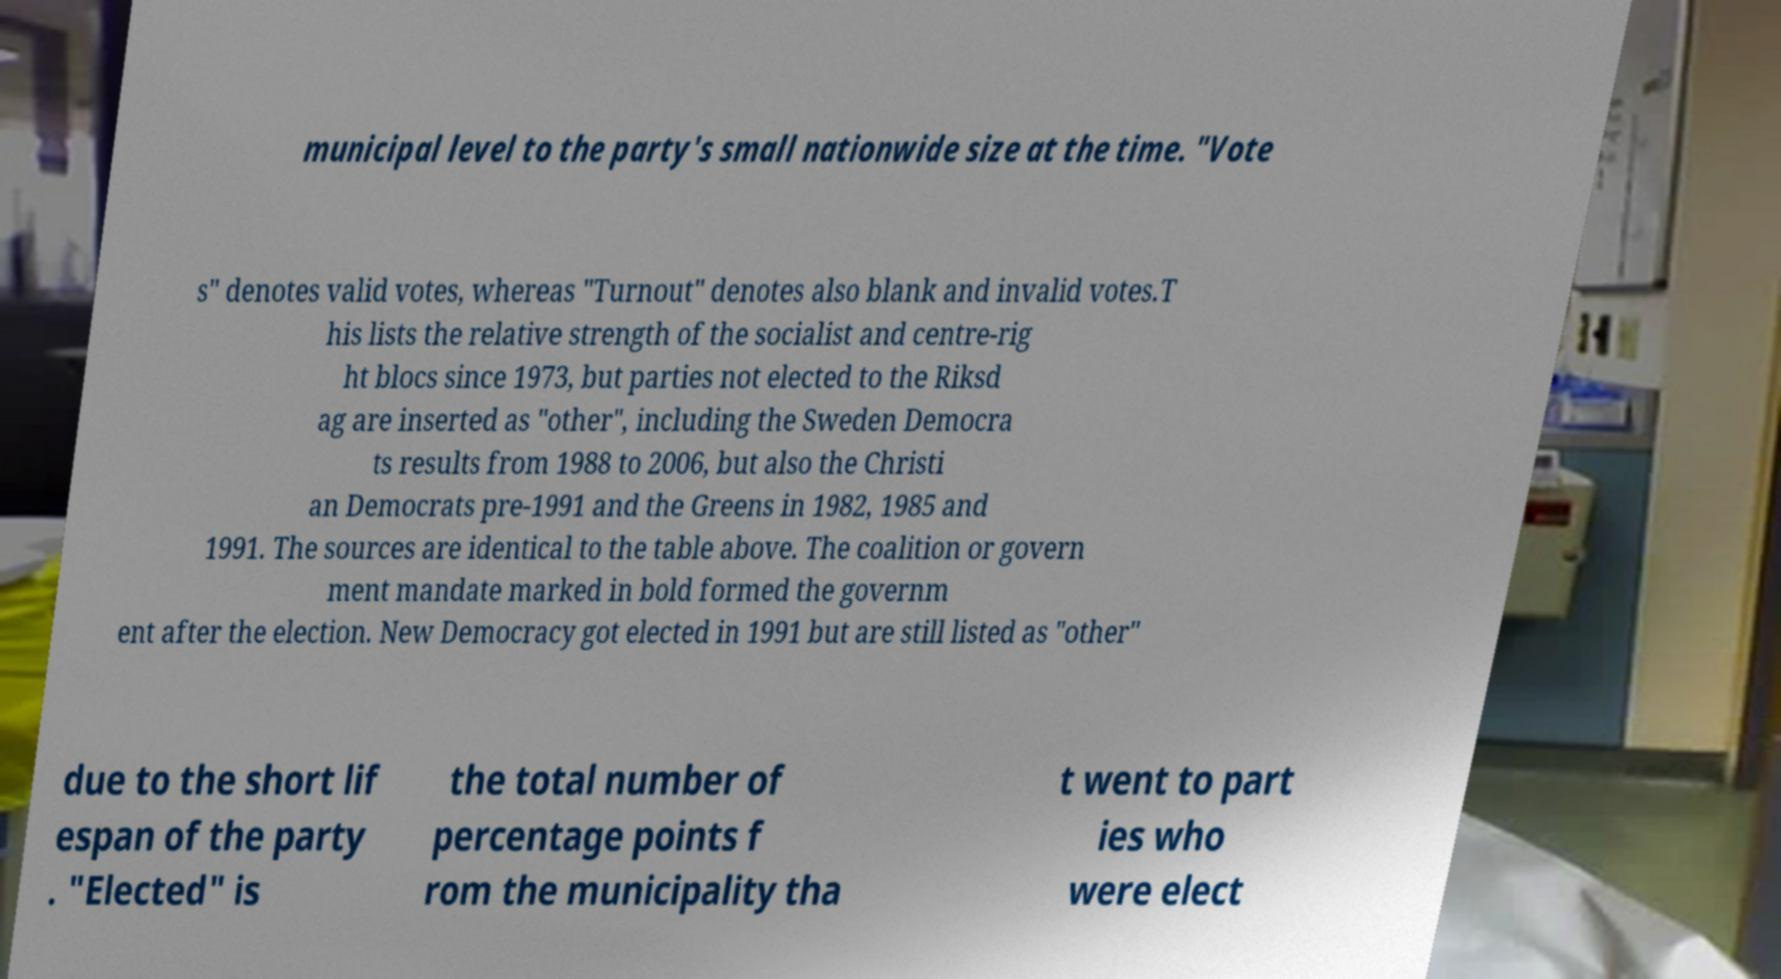Could you extract and type out the text from this image? municipal level to the party's small nationwide size at the time. "Vote s" denotes valid votes, whereas "Turnout" denotes also blank and invalid votes.T his lists the relative strength of the socialist and centre-rig ht blocs since 1973, but parties not elected to the Riksd ag are inserted as "other", including the Sweden Democra ts results from 1988 to 2006, but also the Christi an Democrats pre-1991 and the Greens in 1982, 1985 and 1991. The sources are identical to the table above. The coalition or govern ment mandate marked in bold formed the governm ent after the election. New Democracy got elected in 1991 but are still listed as "other" due to the short lif espan of the party . "Elected" is the total number of percentage points f rom the municipality tha t went to part ies who were elect 